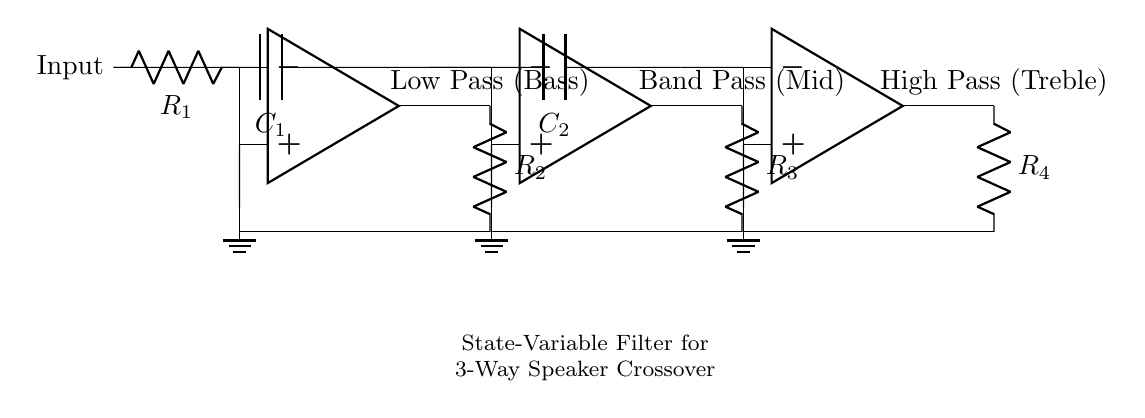What type of filter is represented by this circuit? The circuit represents a state-variable filter, which is characterized by its ability to separate audio signals into low, mid, and high frequency ranges. This is evident from the designation of the outputs as Low Pass, Band Pass, and High Pass.
Answer: state-variable filter How many operational amplifiers are used in this circuit? The circuit contains three operational amplifiers, as indicated by the three separate op amp symbols depicted in the diagram.
Answer: three What component is used to create the low pass filter? The low pass filter is formed by the combination of the first operational amplifier and its associated resistors and capacitors, specifically by recognizing the output labeled as "Low Pass (Bass)" and understanding the feedback loop that involves R1 and R2.
Answer: R1 and R2 What does the capacitor labeled C2 do in the circuit? The capacitor C2 is part of the high pass filter section, enabling only high-frequency signals to pass through while attenuating lower frequencies. This is determined by its connection to the third operational amplifier and its role in the feedback path.
Answer: High Pass Which section of the circuit allows midrange frequencies? The section of the circuit that allows midrange frequencies is the Band Pass section, indicated by the output labeled "Band Pass (Mid)" and connected through the second operational amplifier using R3 and C1.
Answer: Band Pass What is the role of the feedback resistors in the circuit? The feedback resistors (R2, R3, and R4) in the circuit control the gain of each operational amplifier and influence the frequency response of the filters, maintaining the desired filter properties for low, mid, and high frequencies.
Answer: Control gain Which output is associated with bass frequencies? The Low Pass output, which is labeled as "Low Pass (Bass)," is specifically designed to allow bass frequencies to pass while blocking higher frequencies. This function can be derived from the component layout and connections leading to that output.
Answer: Low Pass 